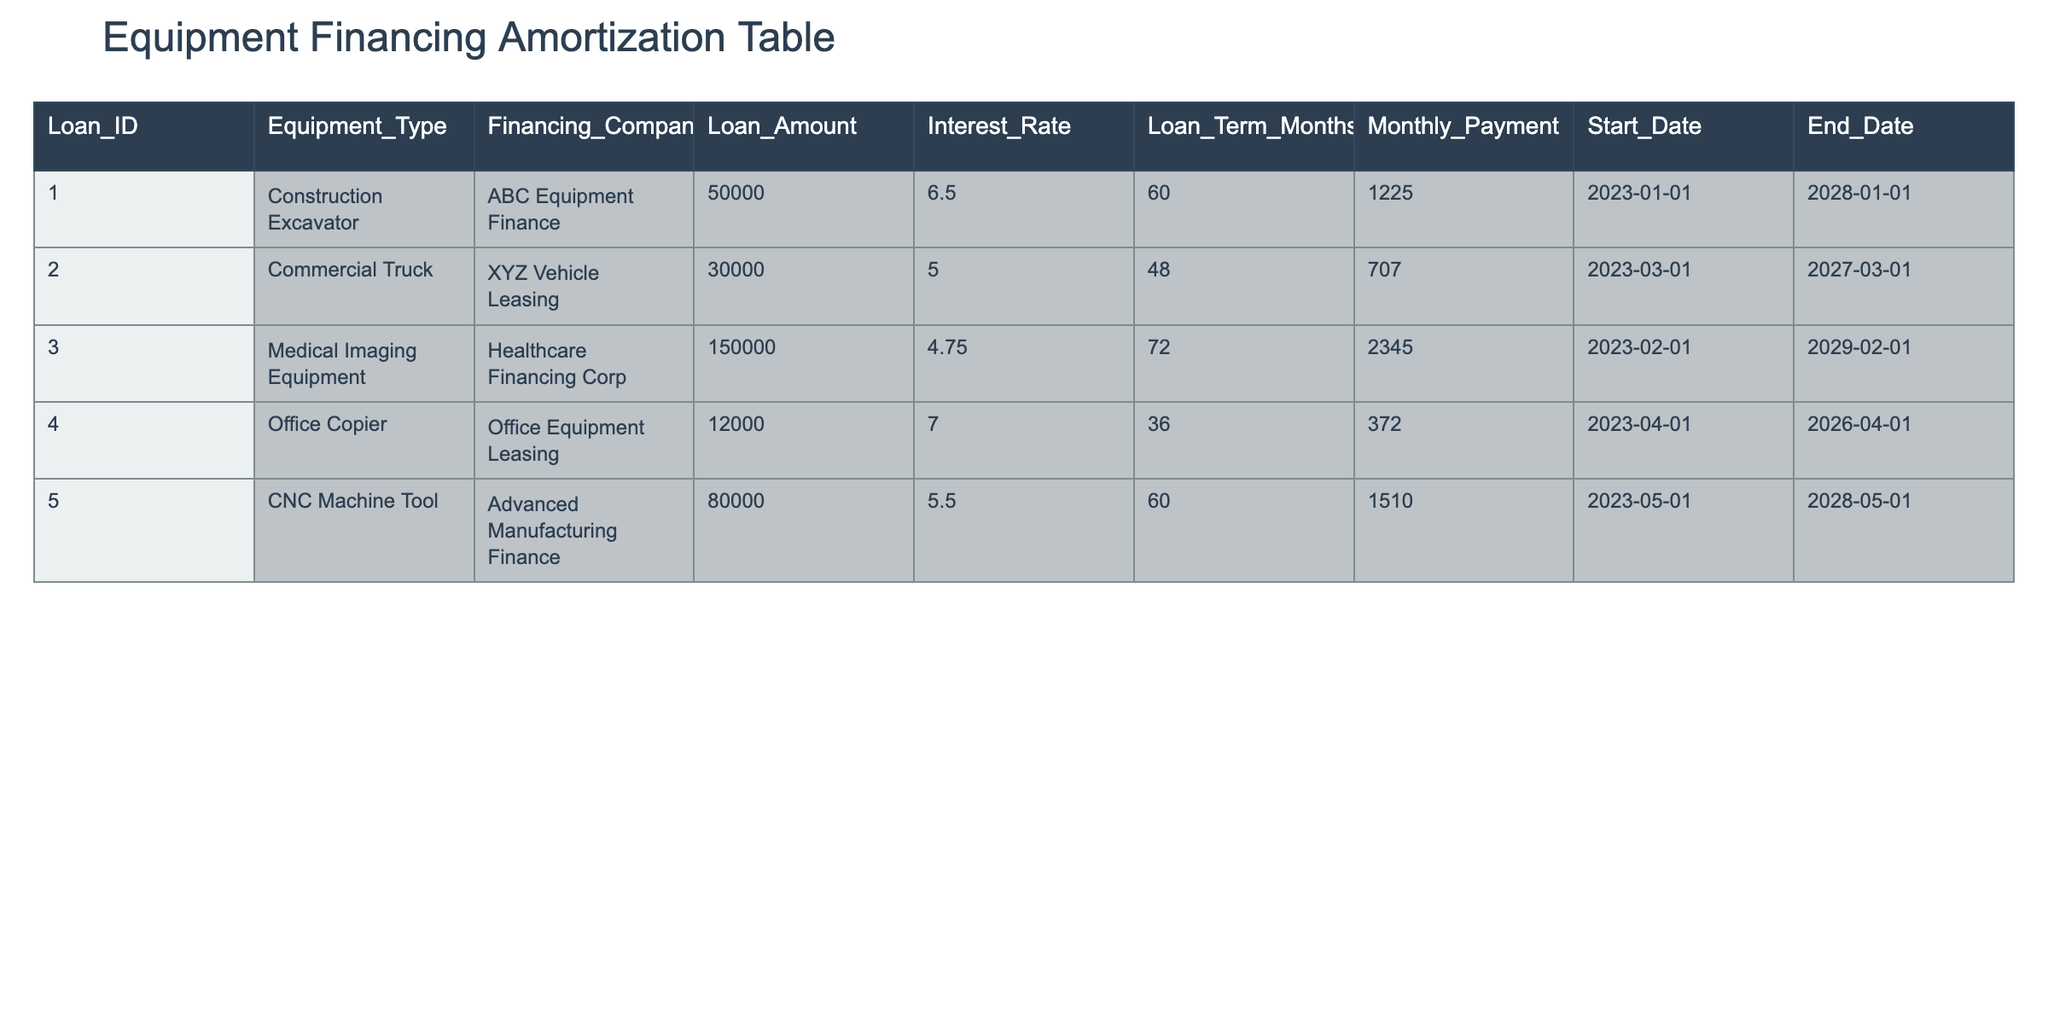What is the loan amount for the CNC Machine Tool? The loan amount for the CNC Machine Tool is listed directly in the table under the "Loan_Amount" column for that particular equipment type. It is $80,000.
Answer: 80000 Which financing company provided the loan for the Commercial Truck? The financing company for the Commercial Truck can be found in the "Financing_Company" column corresponding to that equipment type. It is XYZ Vehicle Leasing.
Answer: XYZ Vehicle Leasing What is the total monthly payment for all equipment financing loans combined? To find the total monthly payment, sum the monthly payments for each equipment listed in the "Monthly_Payment" column: 1225 + 707 + 2345 + 372 + 1510 = 6160.
Answer: 6160 Is the interest rate for the Medical Imaging Equipment higher than 5%? The interest rate for the Medical Imaging Equipment is 4.75%, which is lower than 5%. Therefore, the answer is no.
Answer: No What equipment type has the longest loan term, and what is that term in months? By comparing the "Loan_Term_Months" values in the table, the Medical Imaging Equipment has the longest loan term of 72 months.
Answer: Medical Imaging Equipment, 72 months What is the average interest rate of the loans in the table? To find the average interest rate, add all interest rates (6.5 + 5 + 4.75 + 7 + 5.5) = 29.75 and divide by the number of loans (5). The average is 29.75/5 = 5.95.
Answer: 5.95 Does the Office Copier have a monthly payment greater than $400? The monthly payment for the Office Copier is $372, which is less than $400, so the answer is no.
Answer: No How many loans were financed for a duration exceeding 60 months? By checking the "Loan_Term_Months" column, the Construction Excavator, Medical Imaging Equipment, and CNC Machine Tool have terms greater than 60 months, resulting in a total of 3 loans.
Answer: 3 If the total loan amount for all equipment is calculated, what is the sum? The total loan amount is calculated by summing all the loan amounts: 50000 + 30000 + 150000 + 12000 + 80000 = 248000.
Answer: 248000 